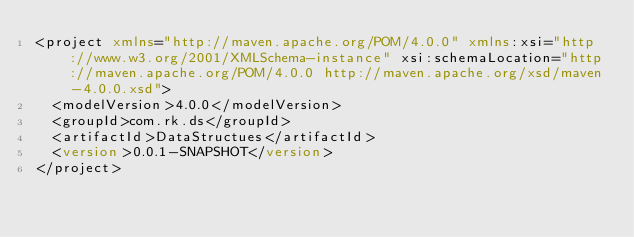<code> <loc_0><loc_0><loc_500><loc_500><_XML_><project xmlns="http://maven.apache.org/POM/4.0.0" xmlns:xsi="http://www.w3.org/2001/XMLSchema-instance" xsi:schemaLocation="http://maven.apache.org/POM/4.0.0 http://maven.apache.org/xsd/maven-4.0.0.xsd">
  <modelVersion>4.0.0</modelVersion>
  <groupId>com.rk.ds</groupId>
  <artifactId>DataStructues</artifactId>
  <version>0.0.1-SNAPSHOT</version>
</project></code> 